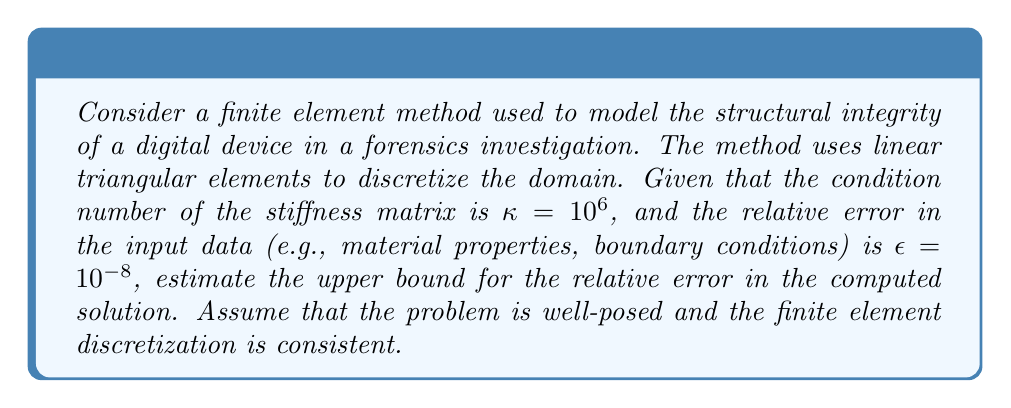Can you solve this math problem? To evaluate the numerical stability of the finite element method in this context, we need to consider the relationship between the condition number of the stiffness matrix, the input error, and the resulting error in the solution. This relationship is governed by the principles of numerical analysis and error propagation.

1. The condition number $\kappa$ of a matrix is a measure of its sensitivity to numerical operations. For a well-posed problem, the relative error in the solution is bounded by:

   $$\frac{\|x - \tilde{x}\|}{\|x\|} \leq \kappa \frac{\|b - \tilde{b}\|}{\|b\|}$$

   where $x$ is the exact solution, $\tilde{x}$ is the computed solution, $b$ is the exact right-hand side, and $\tilde{b}$ is the perturbed right-hand side.

2. In our case, the relative error in the input data is given as $\epsilon = 10^{-8}$. This corresponds to $\frac{\|b - \tilde{b}\|}{\|b\|}$ in the above inequality.

3. The condition number of the stiffness matrix is given as $\kappa = 10^6$.

4. Substituting these values into the inequality:

   $$\frac{\|x - \tilde{x}\|}{\|x\|} \leq 10^6 \cdot 10^{-8} = 10^{-2} = 0.01$$

5. This result means that the upper bound for the relative error in the computed solution is 1% or 0.01.

It's important to note that this is an upper bound, and the actual error may be smaller. However, this analysis provides insight into the potential numerical instability of the method, which is crucial for assessing the reliability of structural integrity models in digital forensics applications.
Answer: The upper bound for the relative error in the computed solution is 0.01 or 1%. 